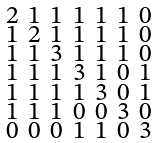Convert formula to latex. <formula><loc_0><loc_0><loc_500><loc_500>\begin{smallmatrix} 2 & 1 & 1 & 1 & 1 & 1 & 0 \\ 1 & 2 & 1 & 1 & 1 & 1 & 0 \\ 1 & 1 & 3 & 1 & 1 & 1 & 0 \\ 1 & 1 & 1 & 3 & 1 & 0 & 1 \\ 1 & 1 & 1 & 1 & 3 & 0 & 1 \\ 1 & 1 & 1 & 0 & 0 & 3 & 0 \\ 0 & 0 & 0 & 1 & 1 & 0 & 3 \end{smallmatrix}</formula> 